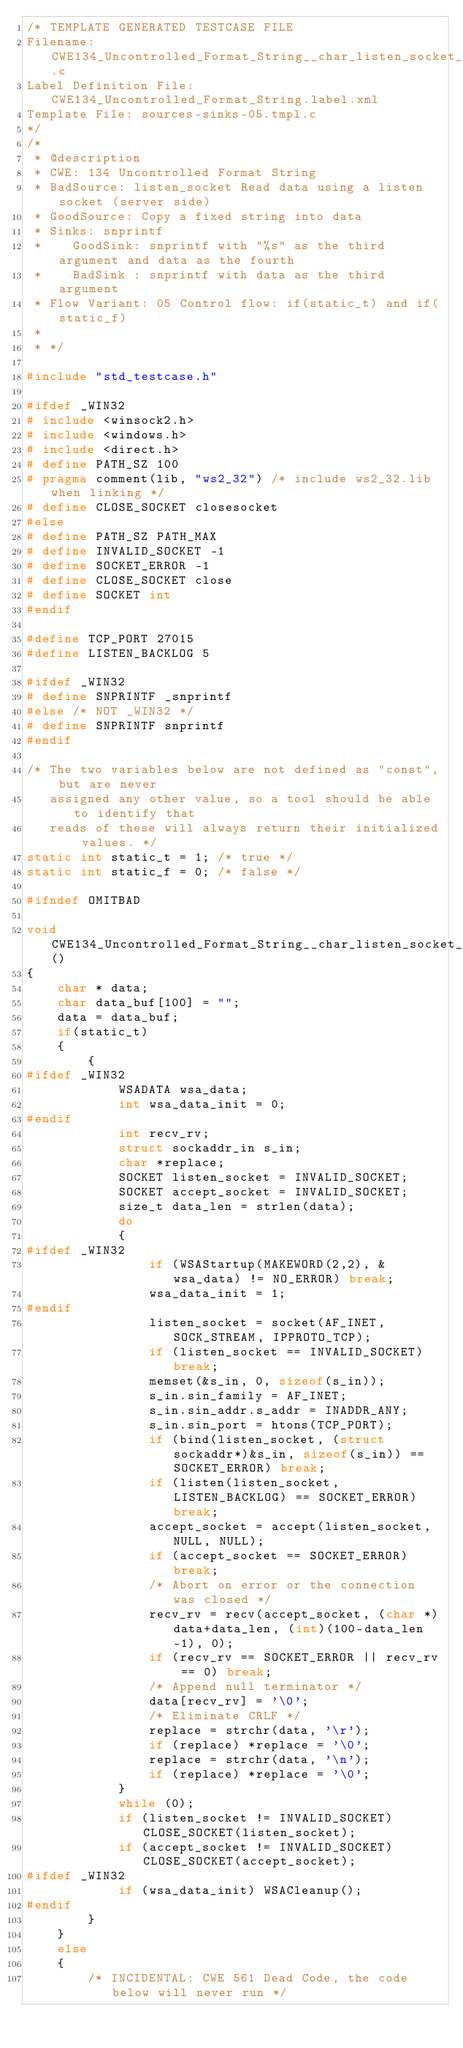<code> <loc_0><loc_0><loc_500><loc_500><_C_>/* TEMPLATE GENERATED TESTCASE FILE
Filename: CWE134_Uncontrolled_Format_String__char_listen_socket_snprintf_05.c
Label Definition File: CWE134_Uncontrolled_Format_String.label.xml
Template File: sources-sinks-05.tmpl.c
*/
/*
 * @description
 * CWE: 134 Uncontrolled Format String
 * BadSource: listen_socket Read data using a listen socket (server side)
 * GoodSource: Copy a fixed string into data
 * Sinks: snprintf
 *    GoodSink: snprintf with "%s" as the third argument and data as the fourth
 *    BadSink : snprintf with data as the third argument
 * Flow Variant: 05 Control flow: if(static_t) and if(static_f)
 *
 * */

#include "std_testcase.h"

#ifdef _WIN32
# include <winsock2.h>
# include <windows.h>
# include <direct.h>
# define PATH_SZ 100
# pragma comment(lib, "ws2_32") /* include ws2_32.lib when linking */
# define CLOSE_SOCKET closesocket
#else
# define PATH_SZ PATH_MAX
# define INVALID_SOCKET -1
# define SOCKET_ERROR -1
# define CLOSE_SOCKET close
# define SOCKET int
#endif

#define TCP_PORT 27015
#define LISTEN_BACKLOG 5

#ifdef _WIN32
# define SNPRINTF _snprintf
#else /* NOT _WIN32 */
# define SNPRINTF snprintf
#endif

/* The two variables below are not defined as "const", but are never
   assigned any other value, so a tool should be able to identify that
   reads of these will always return their initialized values. */
static int static_t = 1; /* true */
static int static_f = 0; /* false */

#ifndef OMITBAD

void CWE134_Uncontrolled_Format_String__char_listen_socket_snprintf_05_bad()
{
    char * data;
    char data_buf[100] = "";
    data = data_buf;
    if(static_t)
    {
        {
#ifdef _WIN32
            WSADATA wsa_data;
            int wsa_data_init = 0;
#endif
            int recv_rv;
            struct sockaddr_in s_in;
            char *replace;
            SOCKET listen_socket = INVALID_SOCKET;
            SOCKET accept_socket = INVALID_SOCKET;
            size_t data_len = strlen(data);
            do
            {
#ifdef _WIN32
                if (WSAStartup(MAKEWORD(2,2), &wsa_data) != NO_ERROR) break;
                wsa_data_init = 1;
#endif
                listen_socket = socket(AF_INET, SOCK_STREAM, IPPROTO_TCP);
                if (listen_socket == INVALID_SOCKET) break;
                memset(&s_in, 0, sizeof(s_in));
                s_in.sin_family = AF_INET;
                s_in.sin_addr.s_addr = INADDR_ANY;
                s_in.sin_port = htons(TCP_PORT);
                if (bind(listen_socket, (struct sockaddr*)&s_in, sizeof(s_in)) == SOCKET_ERROR) break;
                if (listen(listen_socket, LISTEN_BACKLOG) == SOCKET_ERROR) break;
                accept_socket = accept(listen_socket, NULL, NULL);
                if (accept_socket == SOCKET_ERROR) break;
                /* Abort on error or the connection was closed */
                recv_rv = recv(accept_socket, (char *)data+data_len, (int)(100-data_len-1), 0);
                if (recv_rv == SOCKET_ERROR || recv_rv == 0) break;
                /* Append null terminator */
                data[recv_rv] = '\0';
                /* Eliminate CRLF */
                replace = strchr(data, '\r');
                if (replace) *replace = '\0';
                replace = strchr(data, '\n');
                if (replace) *replace = '\0';
            }
            while (0);
            if (listen_socket != INVALID_SOCKET) CLOSE_SOCKET(listen_socket);
            if (accept_socket != INVALID_SOCKET) CLOSE_SOCKET(accept_socket);
#ifdef _WIN32
            if (wsa_data_init) WSACleanup();
#endif
        }
    }
    else
    {
        /* INCIDENTAL: CWE 561 Dead Code, the code below will never run */</code> 